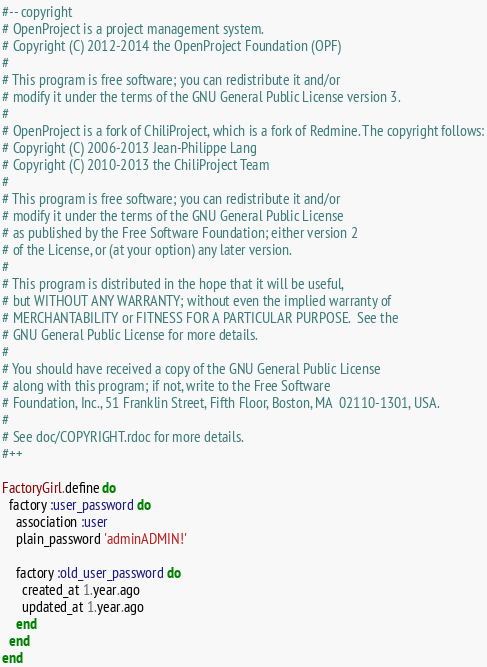Convert code to text. <code><loc_0><loc_0><loc_500><loc_500><_Ruby_>#-- copyright
# OpenProject is a project management system.
# Copyright (C) 2012-2014 the OpenProject Foundation (OPF)
#
# This program is free software; you can redistribute it and/or
# modify it under the terms of the GNU General Public License version 3.
#
# OpenProject is a fork of ChiliProject, which is a fork of Redmine. The copyright follows:
# Copyright (C) 2006-2013 Jean-Philippe Lang
# Copyright (C) 2010-2013 the ChiliProject Team
#
# This program is free software; you can redistribute it and/or
# modify it under the terms of the GNU General Public License
# as published by the Free Software Foundation; either version 2
# of the License, or (at your option) any later version.
#
# This program is distributed in the hope that it will be useful,
# but WITHOUT ANY WARRANTY; without even the implied warranty of
# MERCHANTABILITY or FITNESS FOR A PARTICULAR PURPOSE.  See the
# GNU General Public License for more details.
#
# You should have received a copy of the GNU General Public License
# along with this program; if not, write to the Free Software
# Foundation, Inc., 51 Franklin Street, Fifth Floor, Boston, MA  02110-1301, USA.
#
# See doc/COPYRIGHT.rdoc for more details.
#++

FactoryGirl.define do
  factory :user_password do
    association :user
    plain_password 'adminADMIN!'

    factory :old_user_password do
      created_at 1.year.ago
      updated_at 1.year.ago
    end
  end
end
</code> 